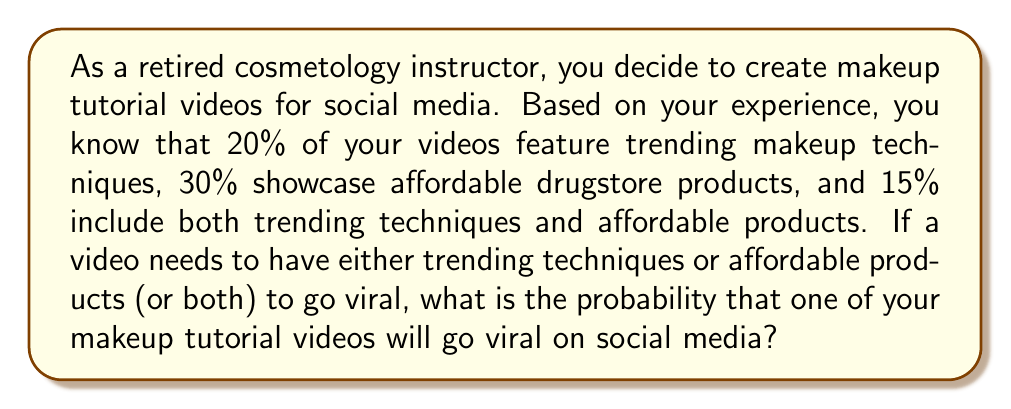Help me with this question. Let's approach this step-by-step using the concept of probability and set theory:

1) Let's define our events:
   A: Video features trending makeup techniques
   B: Video showcases affordable drugstore products

2) We're given the following probabilities:
   $P(A) = 0.20$ (20% feature trending techniques)
   $P(B) = 0.30$ (30% showcase affordable products)
   $P(A \cap B) = 0.15$ (15% include both)

3) We need to find $P(A \cup B)$, which represents the probability of a video going viral (having either trending techniques or affordable products, or both).

4) We can use the addition rule of probability:
   $P(A \cup B) = P(A) + P(B) - P(A \cap B)$

5) Substituting the values:
   $P(A \cup B) = 0.20 + 0.30 - 0.15$

6) Calculating:
   $P(A \cup B) = 0.35$ or 35%

Therefore, the probability that one of your makeup tutorial videos will go viral on social media is 0.35 or 35%.
Answer: The probability that one of your makeup tutorial videos will go viral on social media is $0.35$ or $35\%$. 